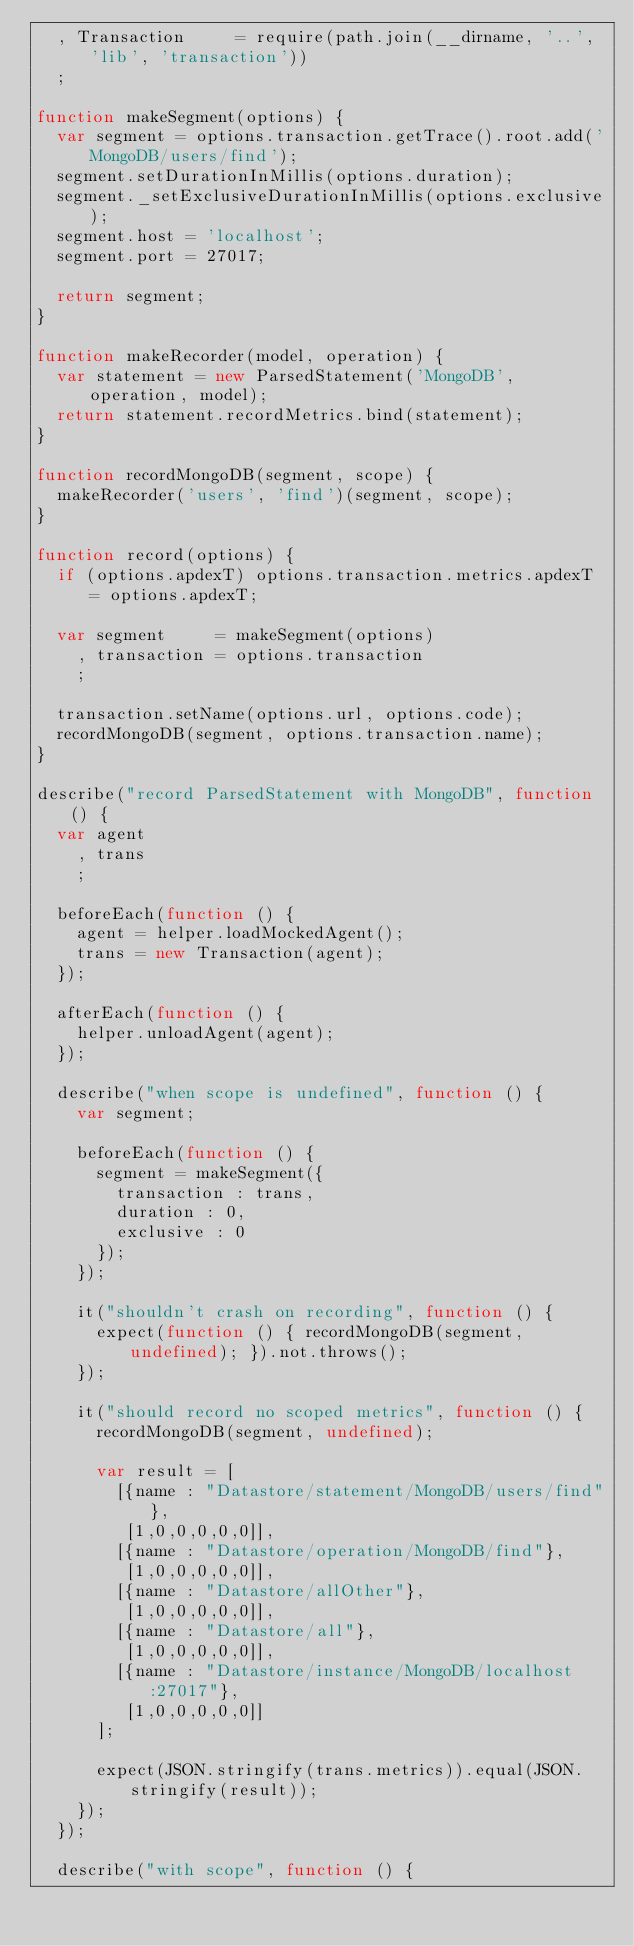<code> <loc_0><loc_0><loc_500><loc_500><_JavaScript_>  , Transaction     = require(path.join(__dirname, '..', 'lib', 'transaction'))
  ;

function makeSegment(options) {
  var segment = options.transaction.getTrace().root.add('MongoDB/users/find');
  segment.setDurationInMillis(options.duration);
  segment._setExclusiveDurationInMillis(options.exclusive);
  segment.host = 'localhost';
  segment.port = 27017;

  return segment;
}

function makeRecorder(model, operation) {
  var statement = new ParsedStatement('MongoDB', operation, model);
  return statement.recordMetrics.bind(statement);
}

function recordMongoDB(segment, scope) {
  makeRecorder('users', 'find')(segment, scope);
}

function record(options) {
  if (options.apdexT) options.transaction.metrics.apdexT = options.apdexT;

  var segment     = makeSegment(options)
    , transaction = options.transaction
    ;

  transaction.setName(options.url, options.code);
  recordMongoDB(segment, options.transaction.name);
}

describe("record ParsedStatement with MongoDB", function () {
  var agent
    , trans
    ;

  beforeEach(function () {
    agent = helper.loadMockedAgent();
    trans = new Transaction(agent);
  });

  afterEach(function () {
    helper.unloadAgent(agent);
  });

  describe("when scope is undefined", function () {
    var segment;

    beforeEach(function () {
      segment = makeSegment({
        transaction : trans,
        duration : 0,
        exclusive : 0
      });
    });

    it("shouldn't crash on recording", function () {
      expect(function () { recordMongoDB(segment, undefined); }).not.throws();
    });

    it("should record no scoped metrics", function () {
      recordMongoDB(segment, undefined);

      var result = [
        [{name : "Datastore/statement/MongoDB/users/find"},
         [1,0,0,0,0,0]],
        [{name : "Datastore/operation/MongoDB/find"},
         [1,0,0,0,0,0]],
        [{name : "Datastore/allOther"},
         [1,0,0,0,0,0]],
        [{name : "Datastore/all"},
         [1,0,0,0,0,0]],
        [{name : "Datastore/instance/MongoDB/localhost:27017"},
         [1,0,0,0,0,0]]
      ];

      expect(JSON.stringify(trans.metrics)).equal(JSON.stringify(result));
    });
  });

  describe("with scope", function () {</code> 